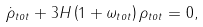Convert formula to latex. <formula><loc_0><loc_0><loc_500><loc_500>\dot { \rho } _ { t o t } + 3 H \left ( 1 + \omega _ { t o t } \right ) \rho _ { t o t } = 0 ,</formula> 